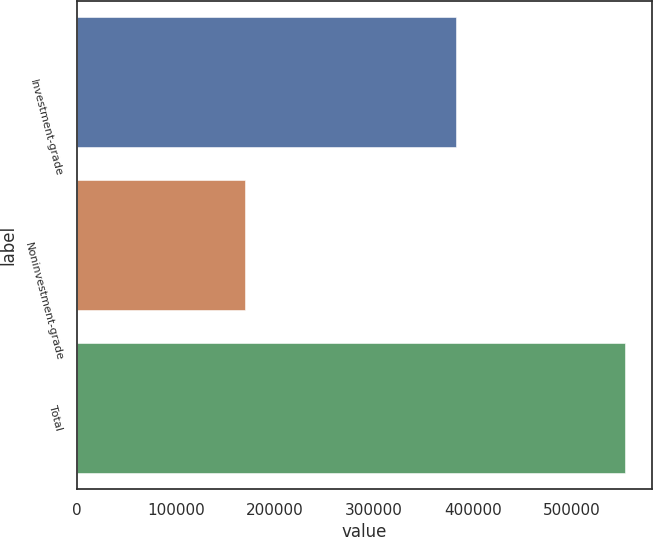Convert chart to OTSL. <chart><loc_0><loc_0><loc_500><loc_500><bar_chart><fcel>Investment-grade<fcel>Noninvestment-grade<fcel>Total<nl><fcel>383586<fcel>170046<fcel>553632<nl></chart> 